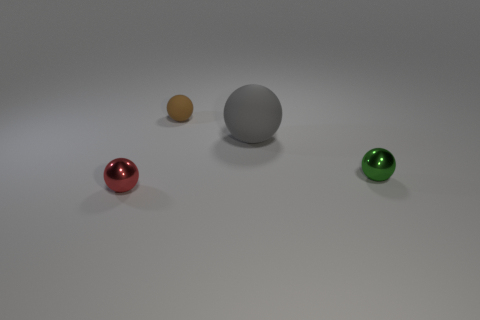How would you describe the lighting in this scene? The scene is softly lit from the upper left, creating gentle shadows on the right sides of the objects. The lighting appears diffused, allowing the colors of the objects to stand out without harsh reflections, giving the setting a calm, studio-like atmosphere. 